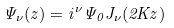<formula> <loc_0><loc_0><loc_500><loc_500>\Psi _ { \nu } ( z ) = i ^ { \nu } \Psi _ { 0 } J _ { \nu } ( 2 K z )</formula> 